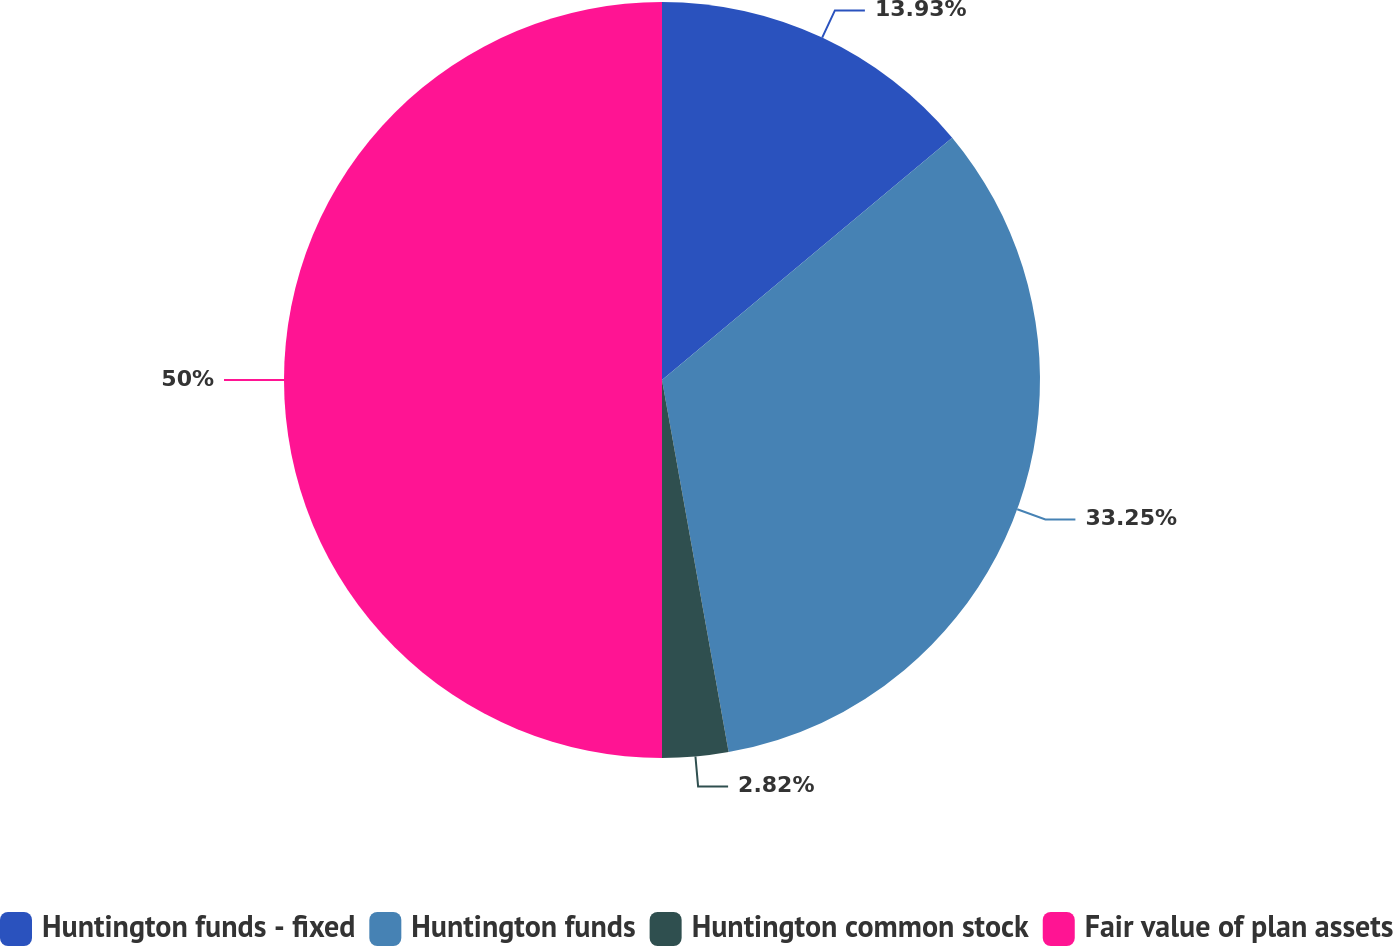<chart> <loc_0><loc_0><loc_500><loc_500><pie_chart><fcel>Huntington funds - fixed<fcel>Huntington funds<fcel>Huntington common stock<fcel>Fair value of plan assets<nl><fcel>13.93%<fcel>33.25%<fcel>2.82%<fcel>50.0%<nl></chart> 